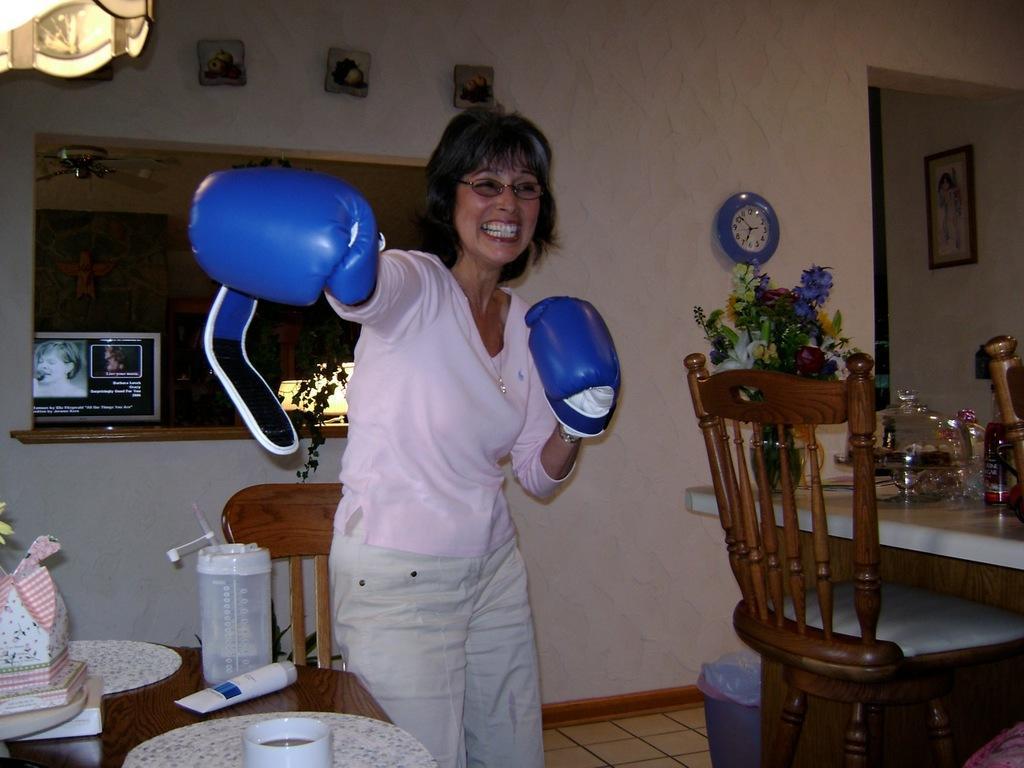In one or two sentences, can you explain what this image depicts? In this image we can see a woman wearing spectacles and boxing gloves on her hand is standing on the floor. In the background, we can see a group of chairs, tables, a jar placed on the table along with a cup, a flower vase and a clock on the wall and some photo frames. 